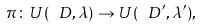<formula> <loc_0><loc_0><loc_500><loc_500>\pi \colon U ( \ D , \lambda ) \to U ( \ D ^ { \prime } , \lambda ^ { \prime } ) ,</formula> 